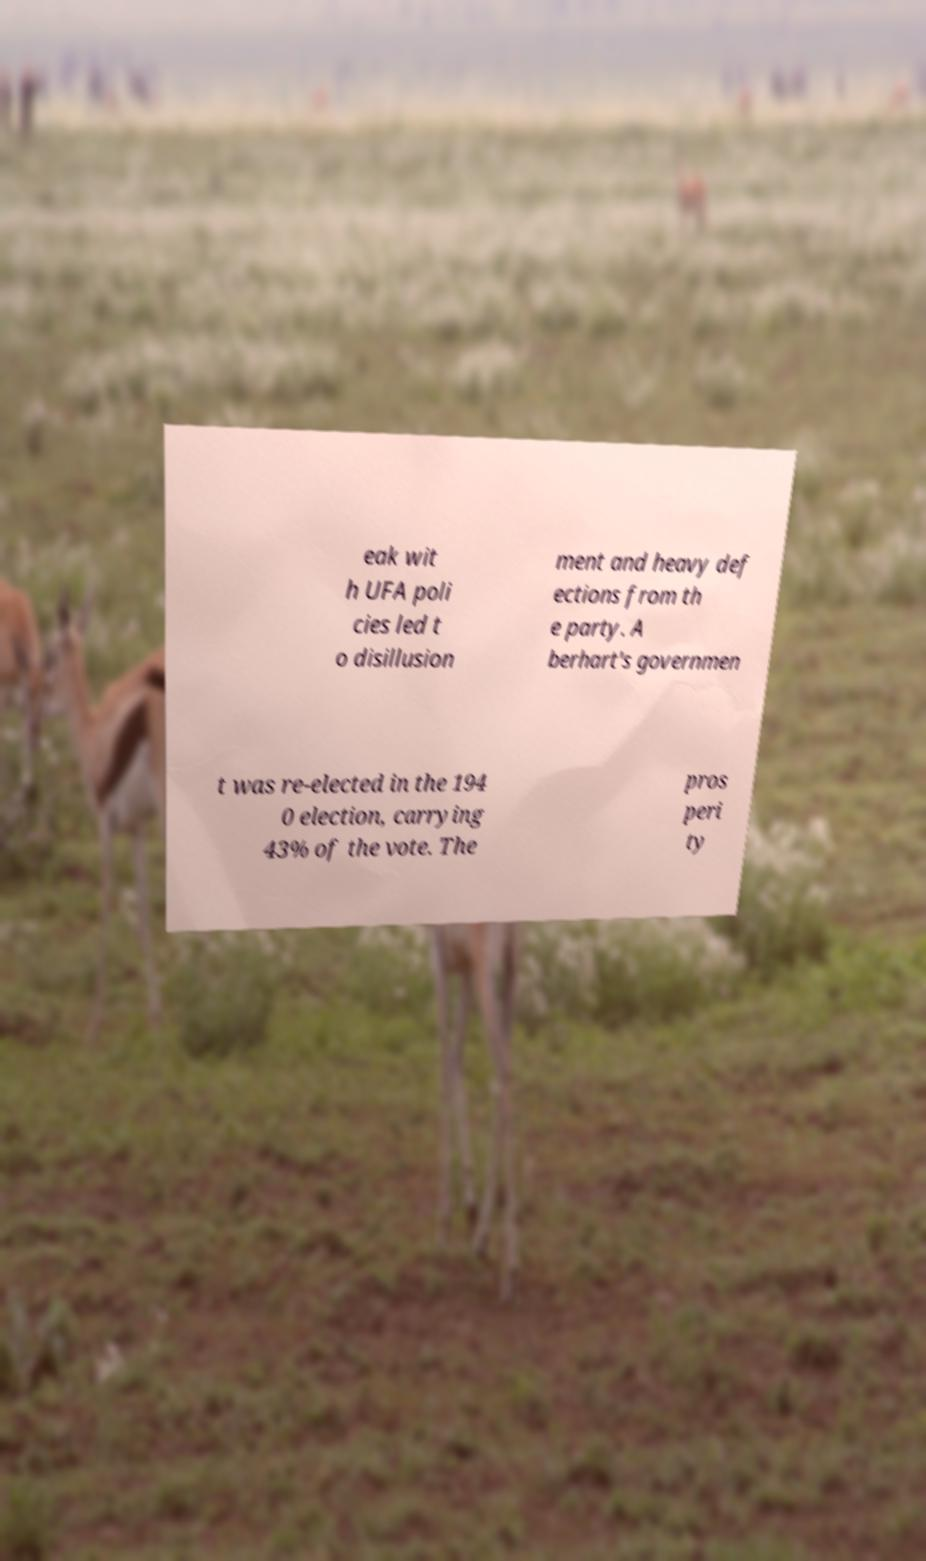Can you read and provide the text displayed in the image?This photo seems to have some interesting text. Can you extract and type it out for me? eak wit h UFA poli cies led t o disillusion ment and heavy def ections from th e party. A berhart's governmen t was re-elected in the 194 0 election, carrying 43% of the vote. The pros peri ty 